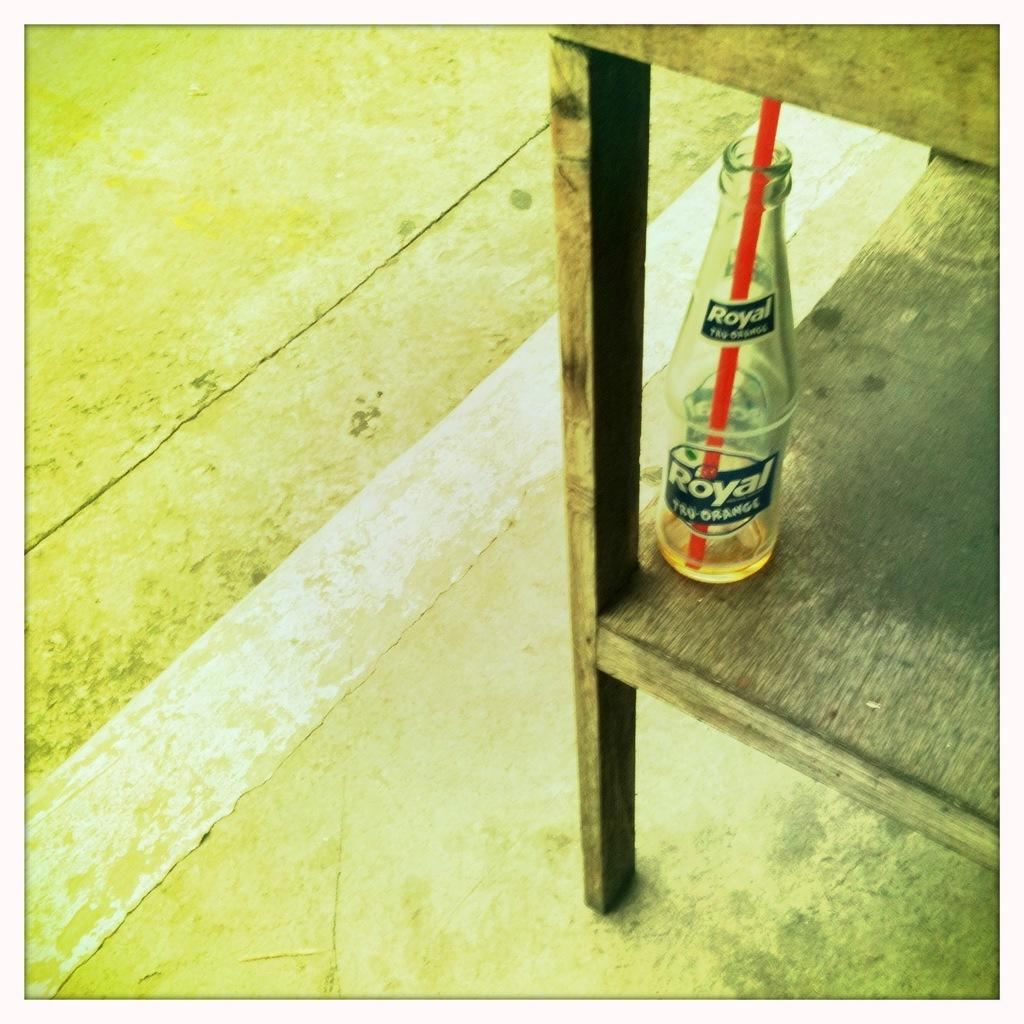<image>
Present a compact description of the photo's key features. The flavor of the Royal bottle is Tru-orange. 